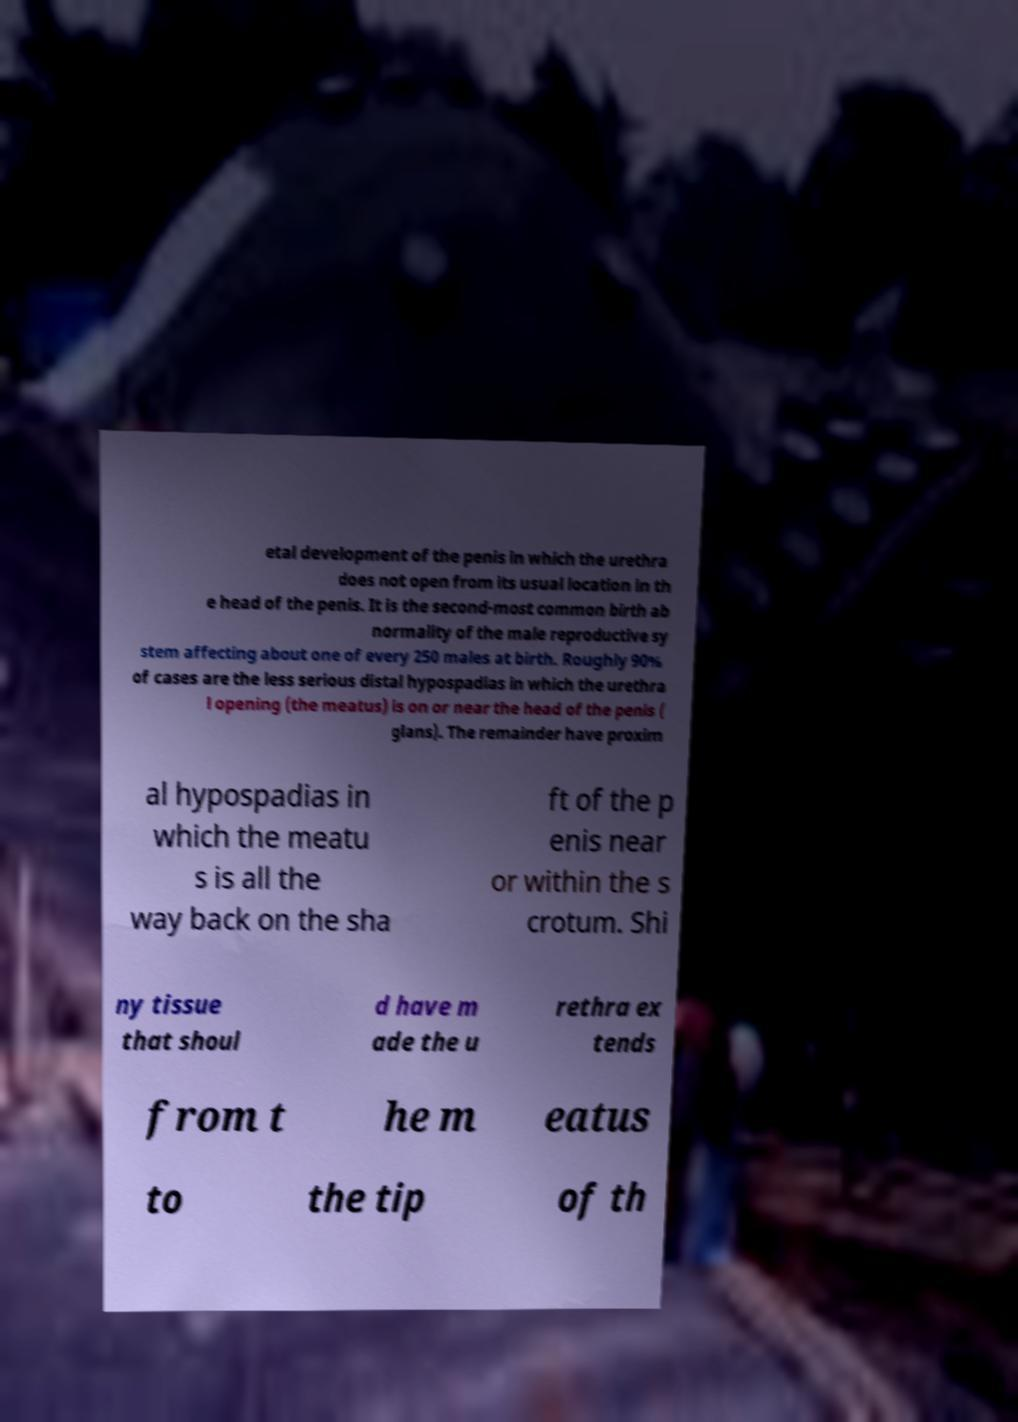Could you extract and type out the text from this image? etal development of the penis in which the urethra does not open from its usual location in th e head of the penis. It is the second-most common birth ab normality of the male reproductive sy stem affecting about one of every 250 males at birth. Roughly 90% of cases are the less serious distal hypospadias in which the urethra l opening (the meatus) is on or near the head of the penis ( glans). The remainder have proxim al hypospadias in which the meatu s is all the way back on the sha ft of the p enis near or within the s crotum. Shi ny tissue that shoul d have m ade the u rethra ex tends from t he m eatus to the tip of th 